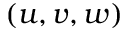Convert formula to latex. <formula><loc_0><loc_0><loc_500><loc_500>( u , v , w )</formula> 